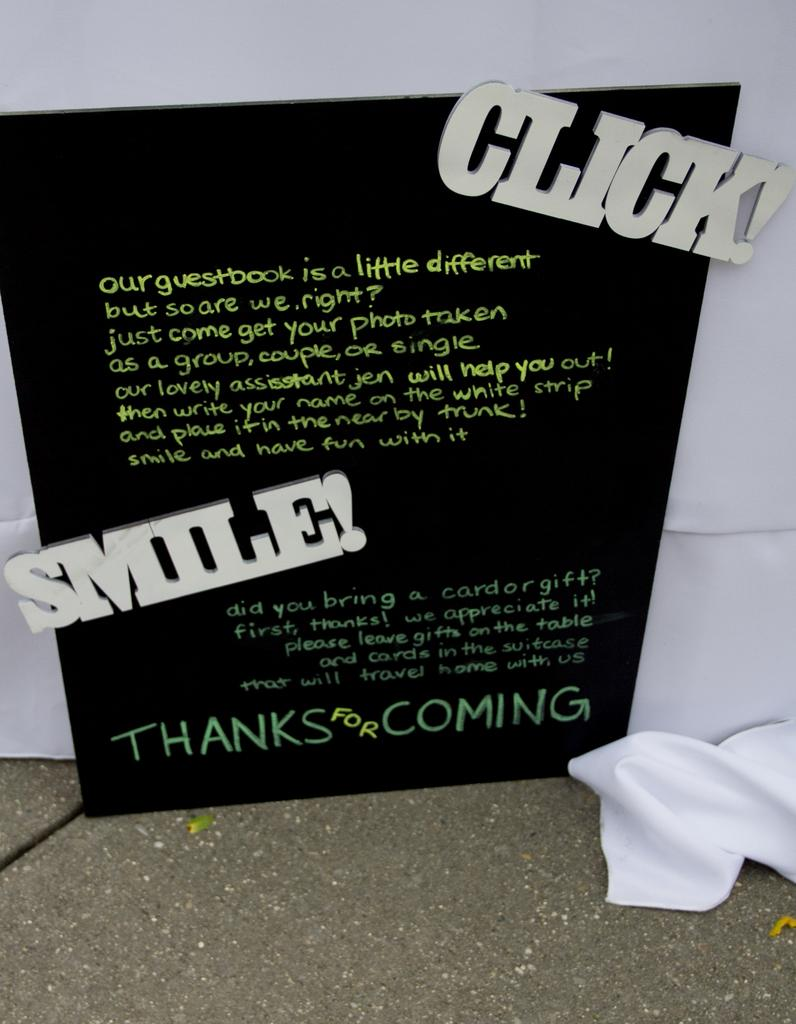What is the main object in the center of the image? There is a black color board in the center of the image. What is written or displayed on the black color board? There is text on the black color board. What color is the cloth in the background of the image? There is a white color cloth in the background of the image. What is the surface beneath the black color board? There is a floor at the bottom of the image. Can you see any cheese on the black color board in the image? No, there is no cheese present on the black color board in the image. 